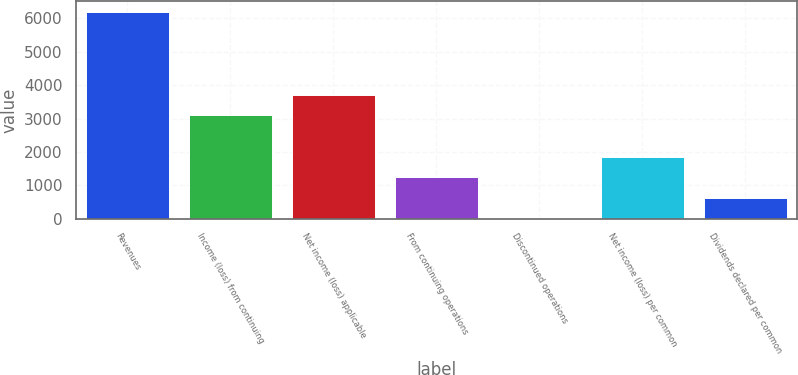<chart> <loc_0><loc_0><loc_500><loc_500><bar_chart><fcel>Revenues<fcel>Income (loss) from continuing<fcel>Net income (loss) applicable<fcel>From continuing operations<fcel>Discontinued operations<fcel>Net income (loss) per common<fcel>Dividends declared per common<nl><fcel>6199<fcel>3099.51<fcel>3719.41<fcel>1239.84<fcel>0.05<fcel>1859.73<fcel>619.94<nl></chart> 